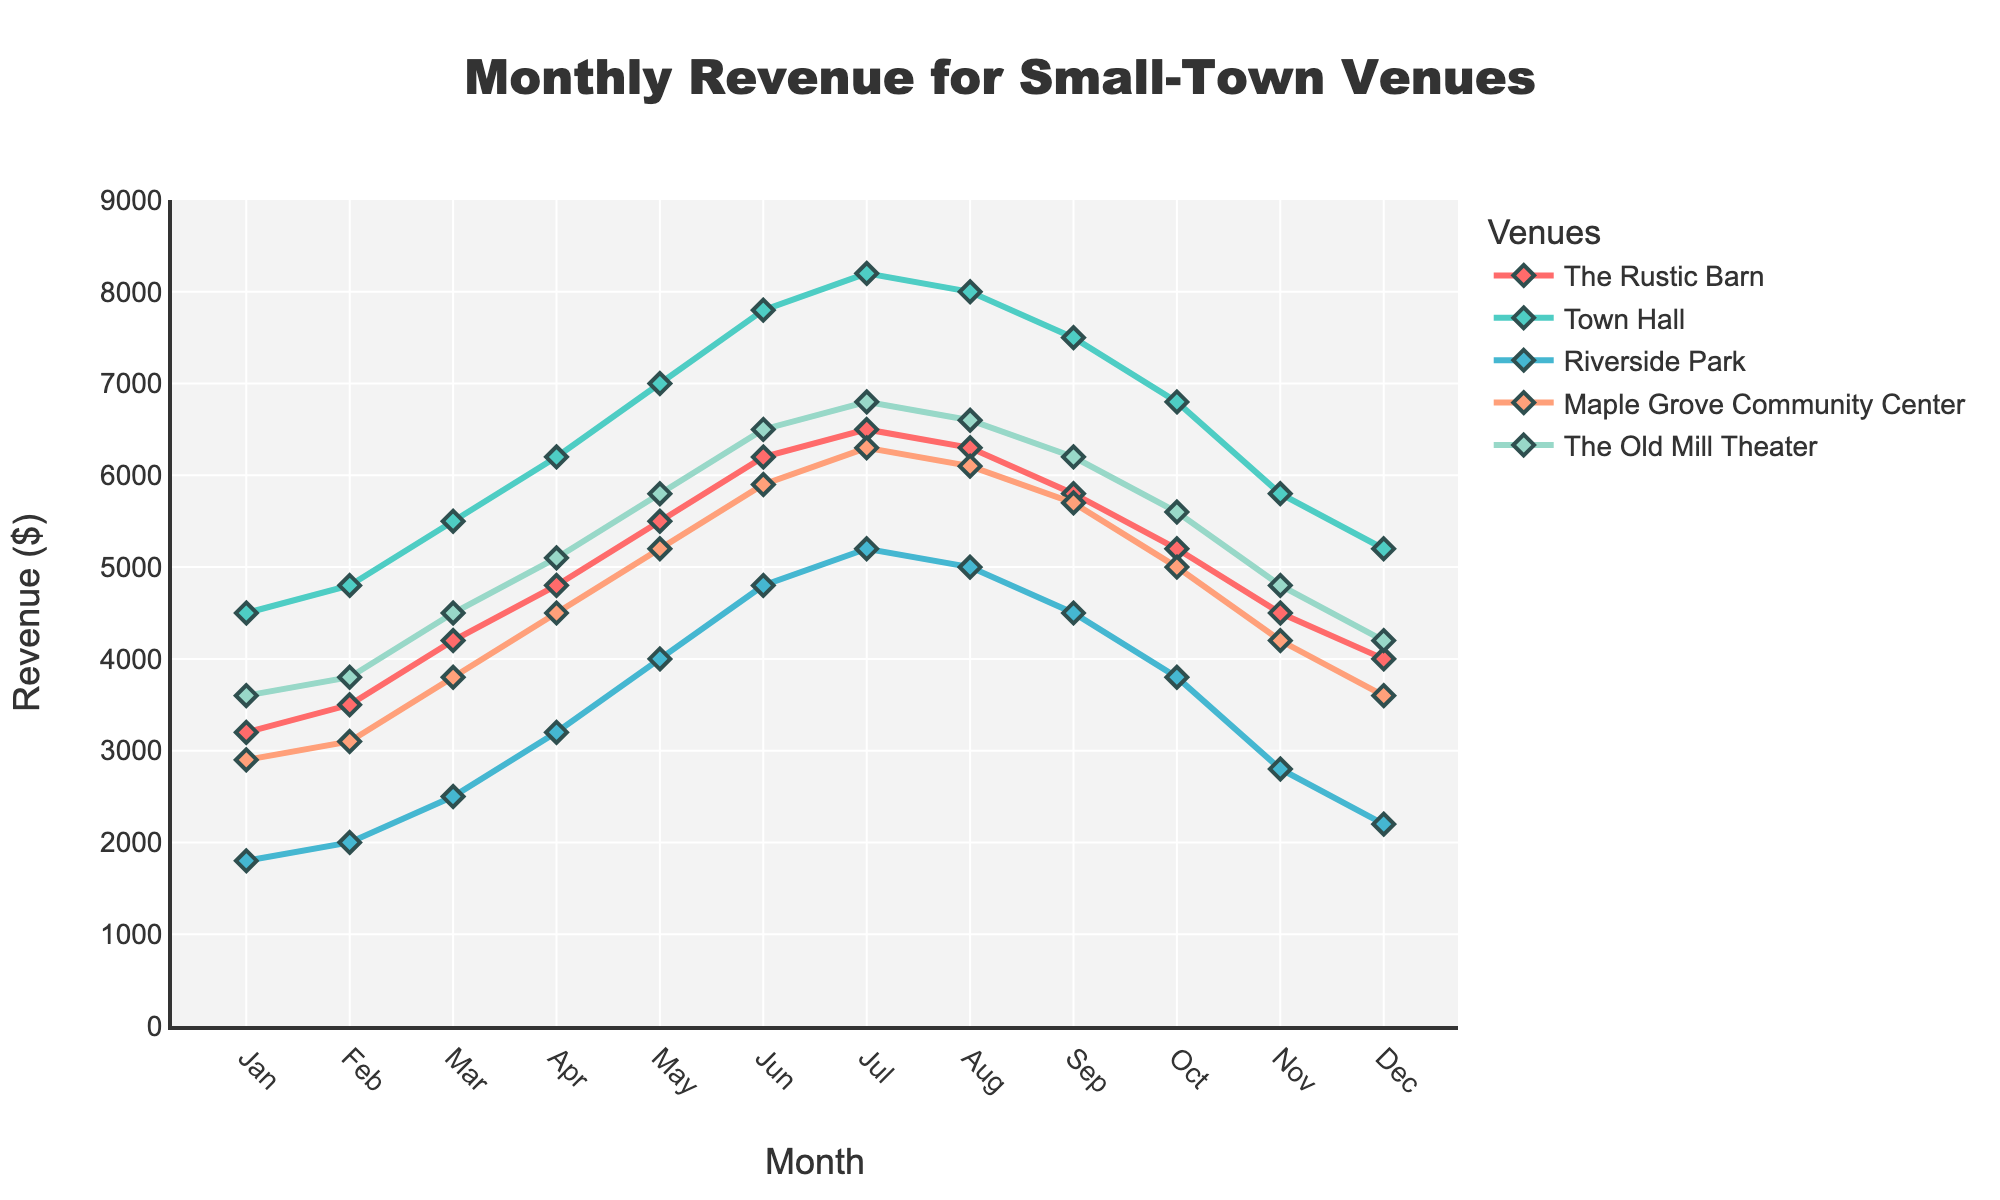What's the overall trend of monthly revenue for Town Hall? From January to July, the revenue for Town Hall shows a consistent increase, peaking in July. After that, from August to December, there's a gradual decline in monthly revenue.
Answer: Consistent increase until July, then a gradual decline Which venue has the highest revenue in June? By observing the height of the lines corresponding to each venue, Town Hall has the highest peak in June compared to the other venues.
Answer: Town Hall Compare the revenues of The Old Mill Theater in March and November. Which month had higher revenue and by how much? The Old Mill Theater had a revenue of $4500 in March and $4800 in November. Subtracting the March revenue from November's: $4800 - $4500 = $300.
Answer: November by $300 What's the average revenue of Riverside Park from May to August? Sum the revenues for Riverside Park from May to August ($4000 + $4800 + $5200 + $5000) = $19000. Then, divide by the number of months (4): $19000 / 4 = $4750.
Answer: $4750 In which month does Maple Grove Community Center have its peak revenue? By observing the line for Maple Grove Community Center, its highest point is in June at $5900.
Answer: June Compare the revenues of The Rustic Barn in February and October. Which month had higher revenue and by how much? The Rustic Barn had a revenue of $3500 in February and $5200 in October. Subtracting the February revenue from October's: $5200 - $3500 = $1700.
Answer: October by $1700 Which venue has the most fluctuating revenue throughout the year? By observing the peaks and troughs of the lines, Town Hall shows the most variation in revenue, indicating significant fluctuations.
Answer: Town Hall What's the total revenue for The Old Mill Theater from January to December? Summing up the monthly revenues for The Old Mill Theater: $3600 + $3800 + $4500 + $5100 + $5800 + $6500 + $6800 + $6600 + $6200 + $5600 + $4800 + $4200 = $63500.
Answer: $63500 